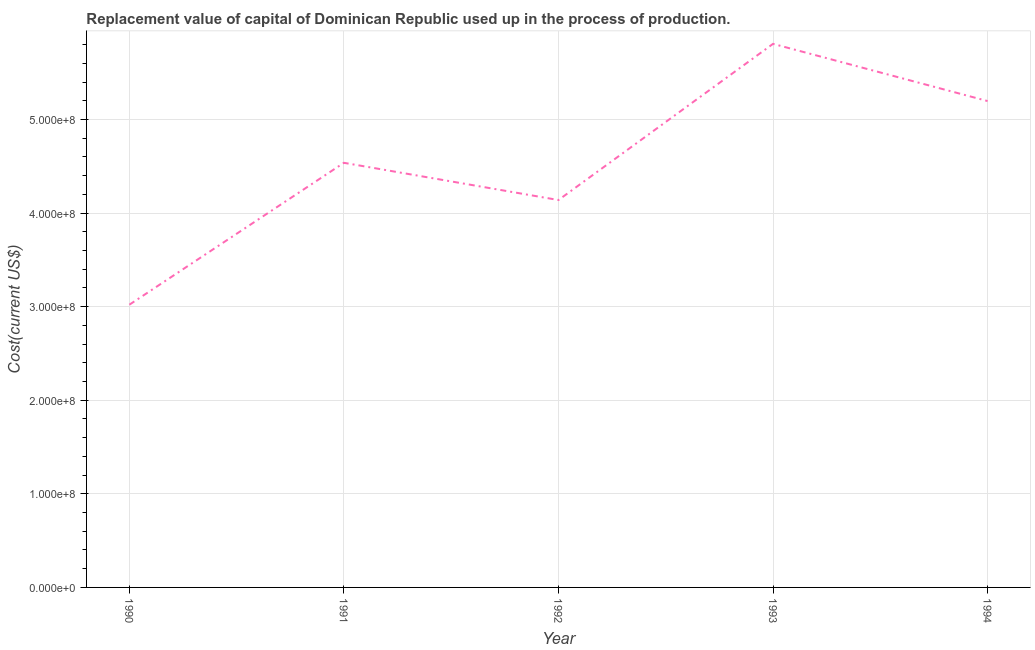What is the consumption of fixed capital in 1992?
Your answer should be very brief. 4.14e+08. Across all years, what is the maximum consumption of fixed capital?
Give a very brief answer. 5.81e+08. Across all years, what is the minimum consumption of fixed capital?
Keep it short and to the point. 3.02e+08. In which year was the consumption of fixed capital maximum?
Your answer should be very brief. 1993. In which year was the consumption of fixed capital minimum?
Your response must be concise. 1990. What is the sum of the consumption of fixed capital?
Your answer should be very brief. 2.27e+09. What is the difference between the consumption of fixed capital in 1990 and 1992?
Your answer should be compact. -1.12e+08. What is the average consumption of fixed capital per year?
Your answer should be very brief. 4.54e+08. What is the median consumption of fixed capital?
Your answer should be compact. 4.54e+08. In how many years, is the consumption of fixed capital greater than 60000000 US$?
Your answer should be compact. 5. Do a majority of the years between 1994 and 1993 (inclusive) have consumption of fixed capital greater than 420000000 US$?
Your answer should be very brief. No. What is the ratio of the consumption of fixed capital in 1990 to that in 1993?
Make the answer very short. 0.52. Is the consumption of fixed capital in 1990 less than that in 1994?
Your answer should be compact. Yes. Is the difference between the consumption of fixed capital in 1992 and 1994 greater than the difference between any two years?
Your response must be concise. No. What is the difference between the highest and the second highest consumption of fixed capital?
Your answer should be very brief. 6.11e+07. Is the sum of the consumption of fixed capital in 1990 and 1992 greater than the maximum consumption of fixed capital across all years?
Your answer should be compact. Yes. What is the difference between the highest and the lowest consumption of fixed capital?
Provide a succinct answer. 2.79e+08. Does the consumption of fixed capital monotonically increase over the years?
Ensure brevity in your answer.  No. How many years are there in the graph?
Make the answer very short. 5. What is the difference between two consecutive major ticks on the Y-axis?
Offer a very short reply. 1.00e+08. Does the graph contain grids?
Provide a short and direct response. Yes. What is the title of the graph?
Your response must be concise. Replacement value of capital of Dominican Republic used up in the process of production. What is the label or title of the Y-axis?
Offer a terse response. Cost(current US$). What is the Cost(current US$) of 1990?
Make the answer very short. 3.02e+08. What is the Cost(current US$) in 1991?
Offer a terse response. 4.54e+08. What is the Cost(current US$) of 1992?
Offer a very short reply. 4.14e+08. What is the Cost(current US$) in 1993?
Keep it short and to the point. 5.81e+08. What is the Cost(current US$) of 1994?
Give a very brief answer. 5.20e+08. What is the difference between the Cost(current US$) in 1990 and 1991?
Keep it short and to the point. -1.52e+08. What is the difference between the Cost(current US$) in 1990 and 1992?
Provide a succinct answer. -1.12e+08. What is the difference between the Cost(current US$) in 1990 and 1993?
Keep it short and to the point. -2.79e+08. What is the difference between the Cost(current US$) in 1990 and 1994?
Offer a very short reply. -2.18e+08. What is the difference between the Cost(current US$) in 1991 and 1992?
Provide a short and direct response. 3.98e+07. What is the difference between the Cost(current US$) in 1991 and 1993?
Make the answer very short. -1.27e+08. What is the difference between the Cost(current US$) in 1991 and 1994?
Your response must be concise. -6.60e+07. What is the difference between the Cost(current US$) in 1992 and 1993?
Keep it short and to the point. -1.67e+08. What is the difference between the Cost(current US$) in 1992 and 1994?
Your answer should be very brief. -1.06e+08. What is the difference between the Cost(current US$) in 1993 and 1994?
Ensure brevity in your answer.  6.11e+07. What is the ratio of the Cost(current US$) in 1990 to that in 1991?
Your response must be concise. 0.67. What is the ratio of the Cost(current US$) in 1990 to that in 1992?
Give a very brief answer. 0.73. What is the ratio of the Cost(current US$) in 1990 to that in 1993?
Your answer should be very brief. 0.52. What is the ratio of the Cost(current US$) in 1990 to that in 1994?
Provide a short and direct response. 0.58. What is the ratio of the Cost(current US$) in 1991 to that in 1992?
Make the answer very short. 1.1. What is the ratio of the Cost(current US$) in 1991 to that in 1993?
Provide a short and direct response. 0.78. What is the ratio of the Cost(current US$) in 1991 to that in 1994?
Make the answer very short. 0.87. What is the ratio of the Cost(current US$) in 1992 to that in 1993?
Your response must be concise. 0.71. What is the ratio of the Cost(current US$) in 1992 to that in 1994?
Make the answer very short. 0.8. What is the ratio of the Cost(current US$) in 1993 to that in 1994?
Offer a very short reply. 1.12. 